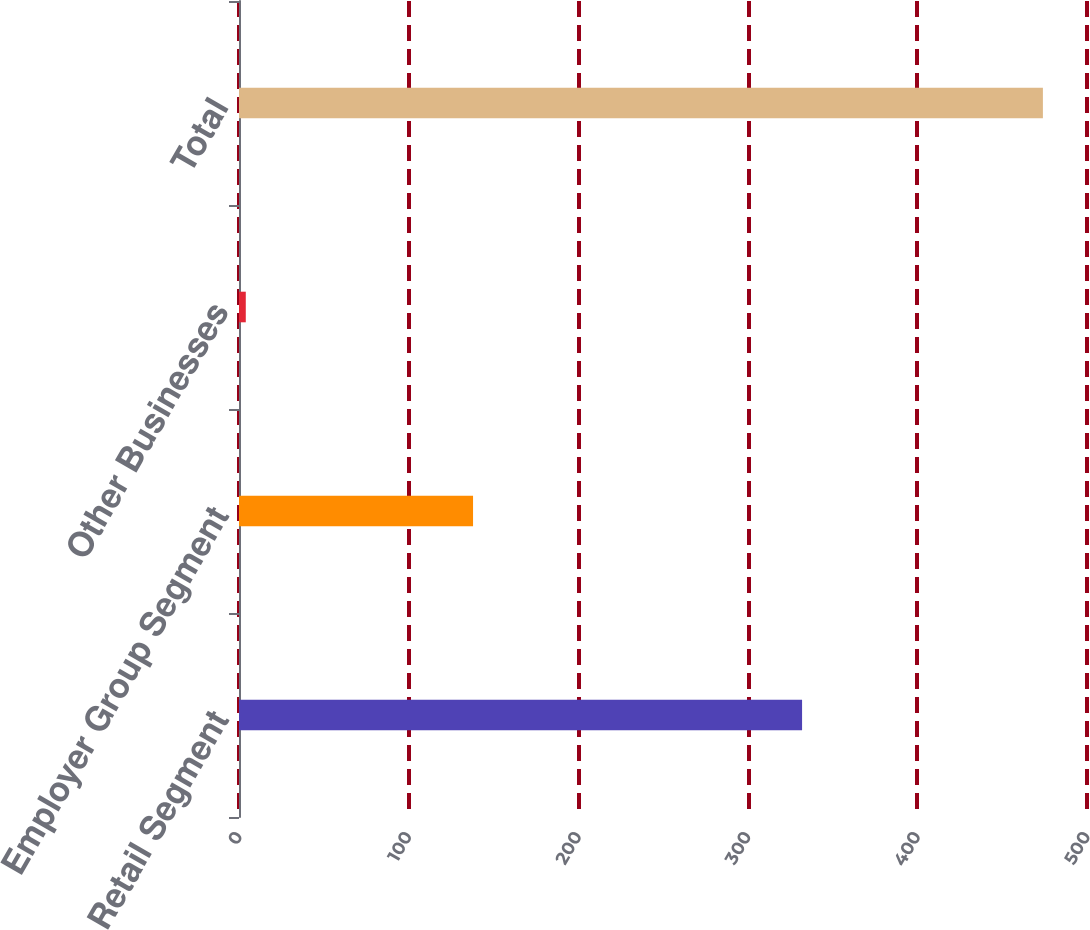Convert chart to OTSL. <chart><loc_0><loc_0><loc_500><loc_500><bar_chart><fcel>Retail Segment<fcel>Employer Group Segment<fcel>Other Businesses<fcel>Total<nl><fcel>332<fcel>138<fcel>4<fcel>474<nl></chart> 